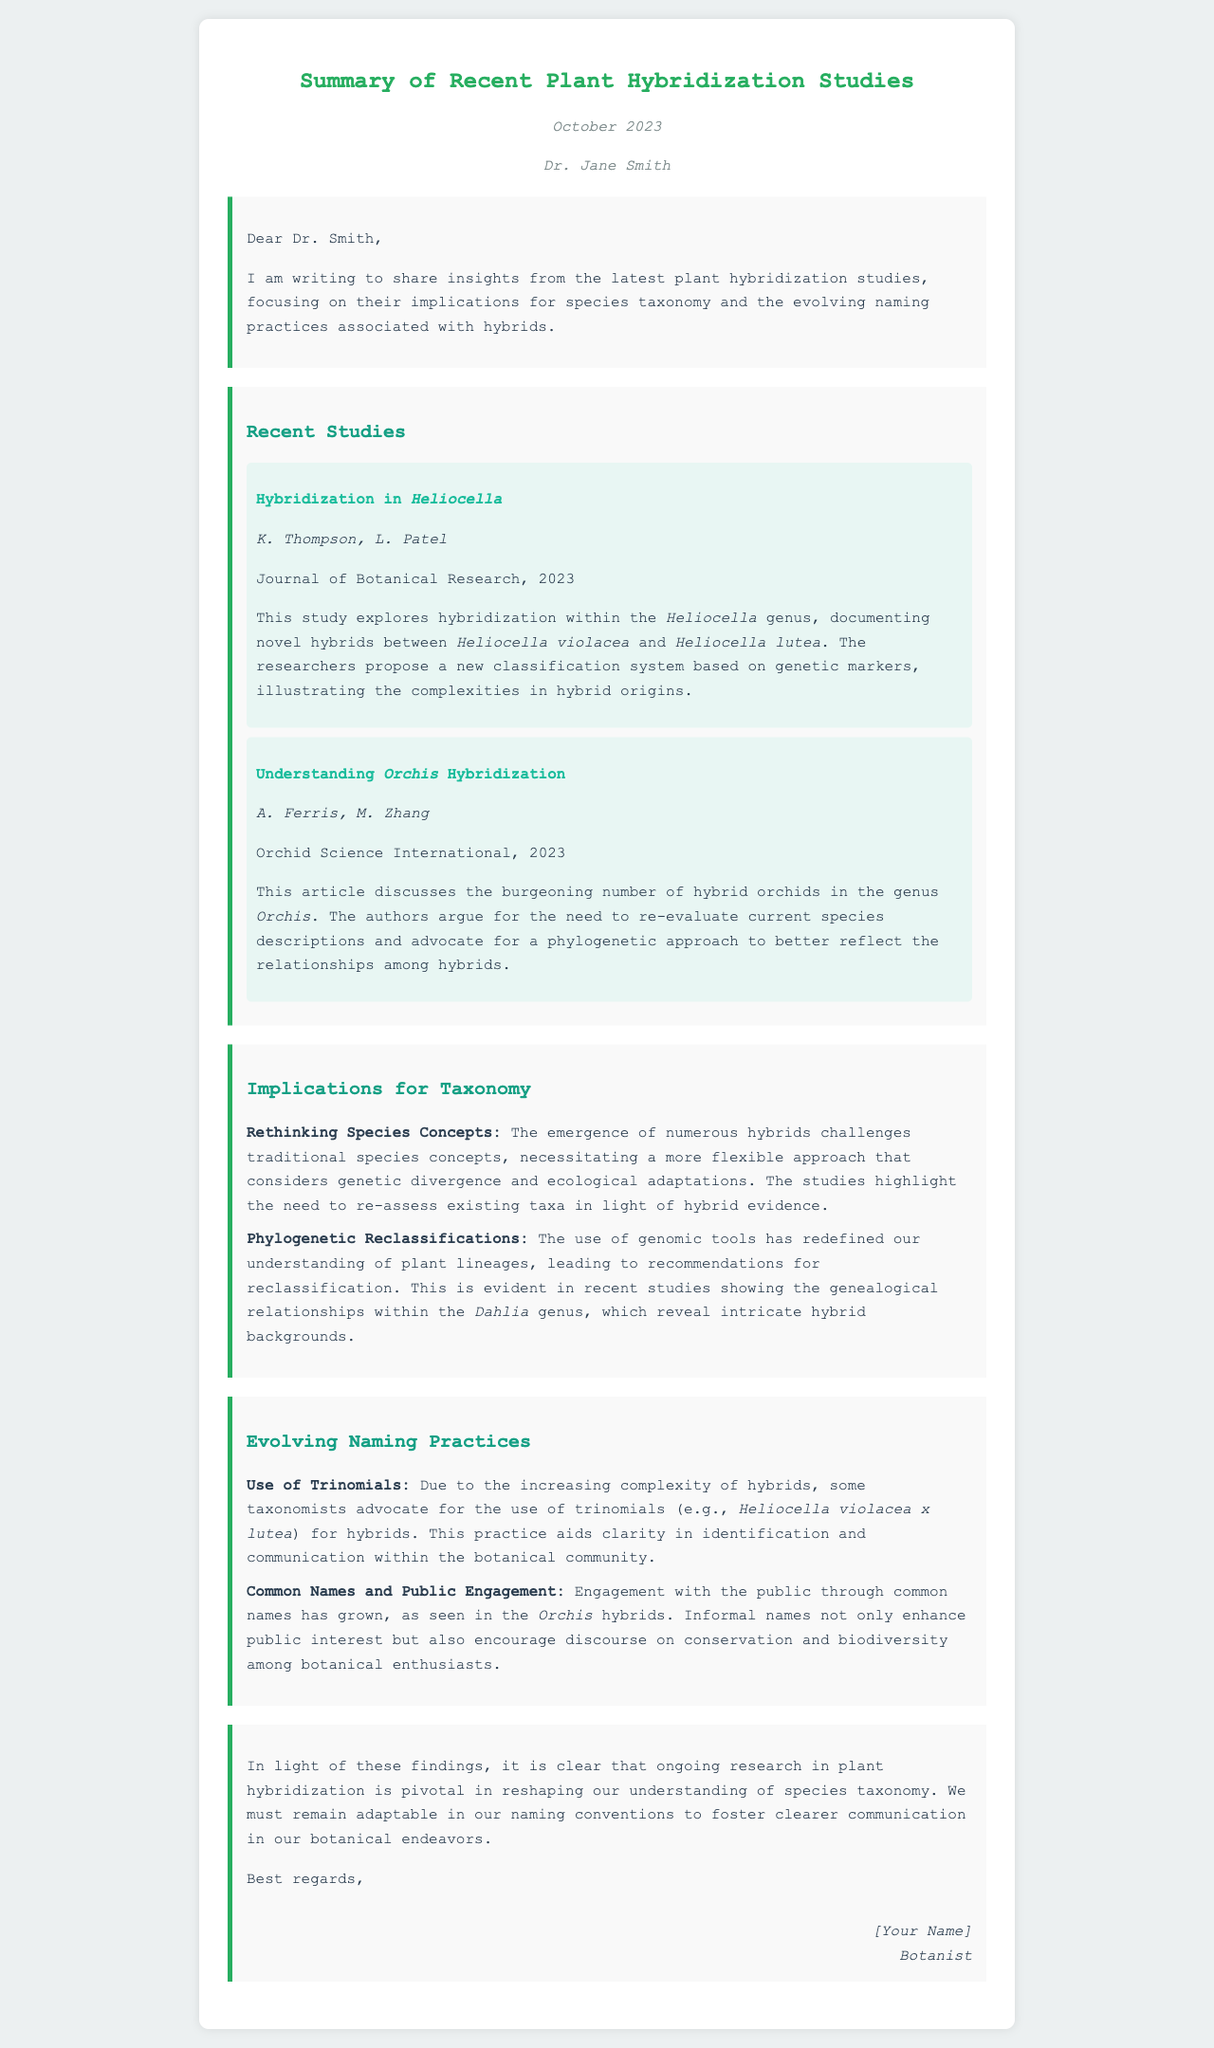What is the title of the letter? The title of the letter is displayed prominently at the top of the document, which is "Summary of Recent Plant Hybridization Studies."
Answer: Summary of Recent Plant Hybridization Studies Who is the recipient of the letter? The recipient of the letter is mentioned immediately after the date in the letter, identifying Dr. Jane Smith as the recipient.
Answer: Dr. Jane Smith What are the names of the authors of the first study? The authors of the first study are listed just below the title of the study and are K. Thompson and L. Patel.
Answer: K. Thompson, L. Patel What is the publication year of the studies discussed? The publication year is indicated in each study summary, which states that the studies were published in 2023.
Answer: 2023 What taxonomy-related topic is addressed in the implications section? The implications section discusses various taxonomy-related topics, notably "Rethinking Species Concepts" and "Phylogenetic Reclassifications."
Answer: Rethinking Species Concepts What is the highlighted approach for hybrid naming practices? The letter mentions that some taxonomists advocate for the use of trinomials for clearer identification of hybrids.
Answer: Trinomials Which genus is highlighted for its hybridization study in the letter? The document explicitly mentions studies on the genus Heliocella and Orchis.
Answer: Heliocella What is a central theme of the letter regarding plant hybridization? The central theme revolves around the implications of hybridization studies on species taxonomy and naming practices.
Answer: Implications for species taxonomy What style of communication does the author suggest for public engagement? The author highlights the use of common names as a means to enhance public interest and engagement in botanical discourse.
Answer: Common names 